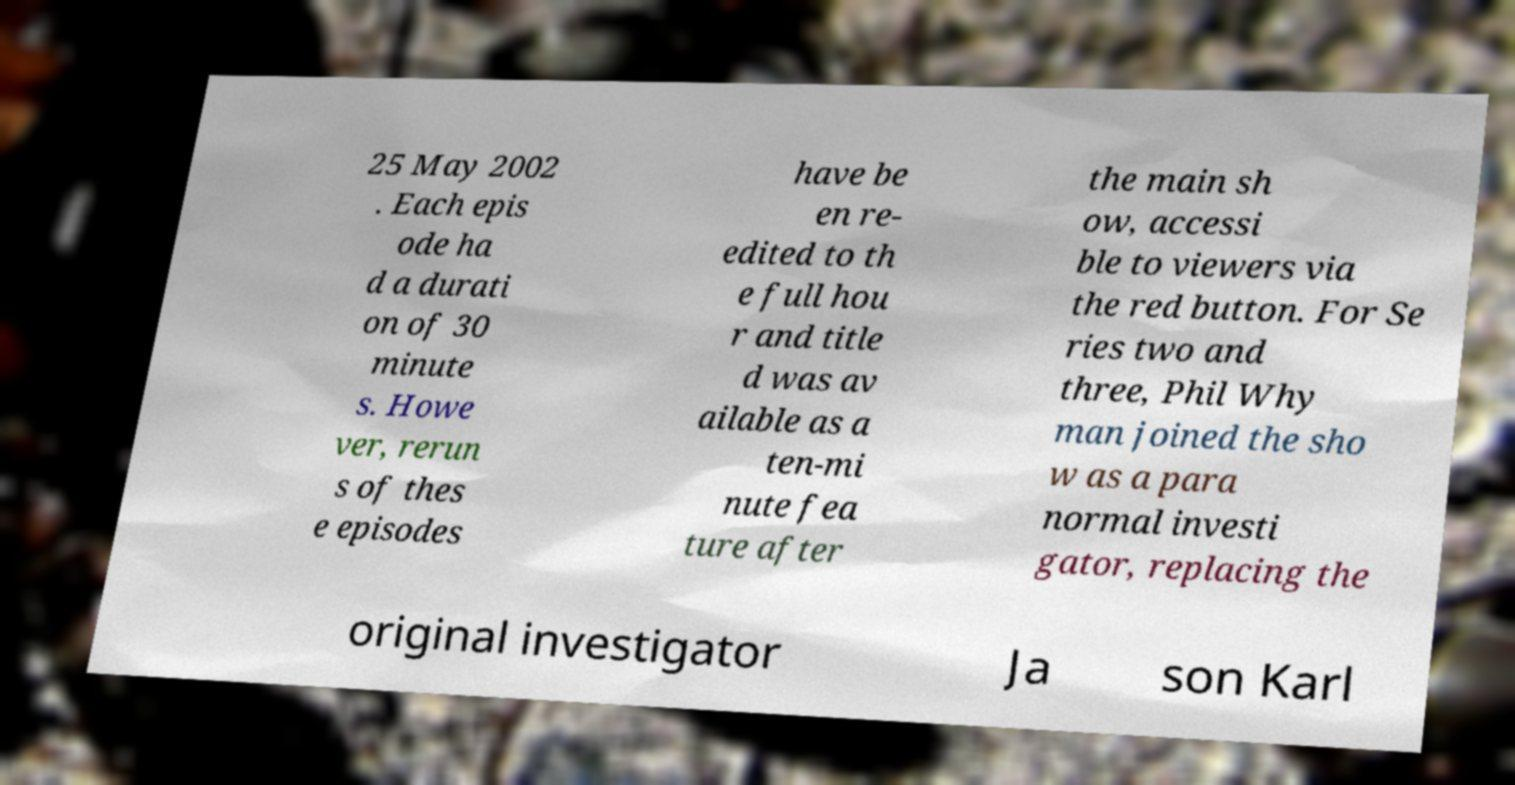For documentation purposes, I need the text within this image transcribed. Could you provide that? 25 May 2002 . Each epis ode ha d a durati on of 30 minute s. Howe ver, rerun s of thes e episodes have be en re- edited to th e full hou r and title d was av ailable as a ten-mi nute fea ture after the main sh ow, accessi ble to viewers via the red button. For Se ries two and three, Phil Why man joined the sho w as a para normal investi gator, replacing the original investigator Ja son Karl 